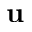Convert formula to latex. <formula><loc_0><loc_0><loc_500><loc_500>u</formula> 